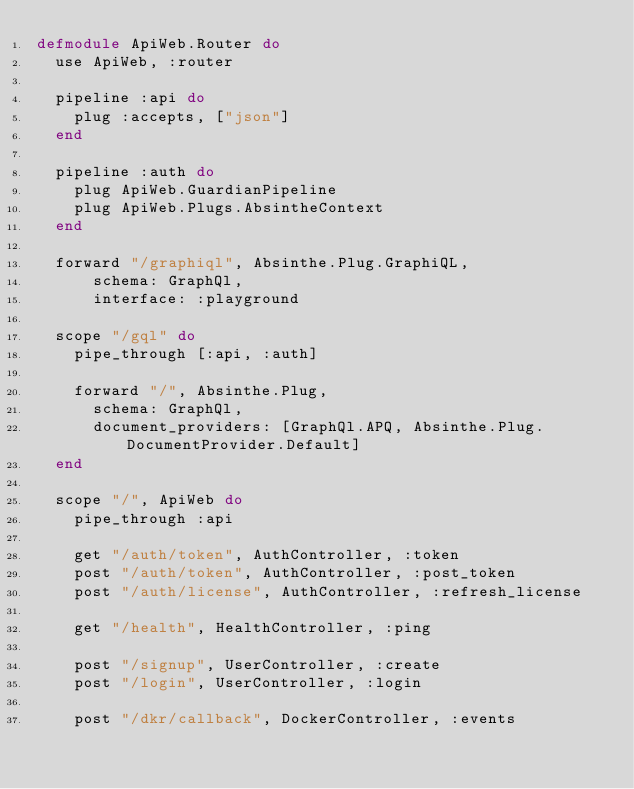Convert code to text. <code><loc_0><loc_0><loc_500><loc_500><_Elixir_>defmodule ApiWeb.Router do
  use ApiWeb, :router

  pipeline :api do
    plug :accepts, ["json"]
  end

  pipeline :auth do
    plug ApiWeb.GuardianPipeline
    plug ApiWeb.Plugs.AbsintheContext
  end

  forward "/graphiql", Absinthe.Plug.GraphiQL,
      schema: GraphQl,
      interface: :playground

  scope "/gql" do
    pipe_through [:api, :auth]

    forward "/", Absinthe.Plug,
      schema: GraphQl,
      document_providers: [GraphQl.APQ, Absinthe.Plug.DocumentProvider.Default]
  end

  scope "/", ApiWeb do
    pipe_through :api

    get "/auth/token", AuthController, :token
    post "/auth/token", AuthController, :post_token
    post "/auth/license", AuthController, :refresh_license

    get "/health", HealthController, :ping

    post "/signup", UserController, :create
    post "/login", UserController, :login

    post "/dkr/callback", DockerController, :events
</code> 